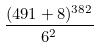<formula> <loc_0><loc_0><loc_500><loc_500>\frac { ( 4 9 1 + 8 ) ^ { 3 8 2 } } { 6 ^ { 2 } }</formula> 